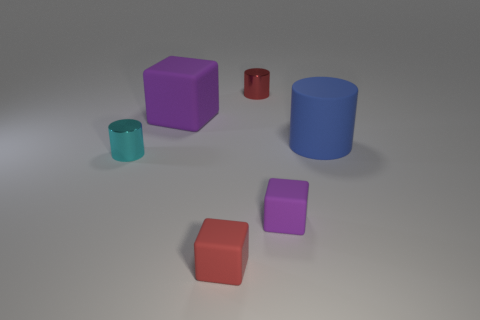Add 3 tiny blue metal objects. How many objects exist? 9 Add 5 blue matte cylinders. How many blue matte cylinders exist? 6 Subtract 0 yellow cylinders. How many objects are left? 6 Subtract all large purple matte cubes. Subtract all tiny red things. How many objects are left? 3 Add 2 large cubes. How many large cubes are left? 3 